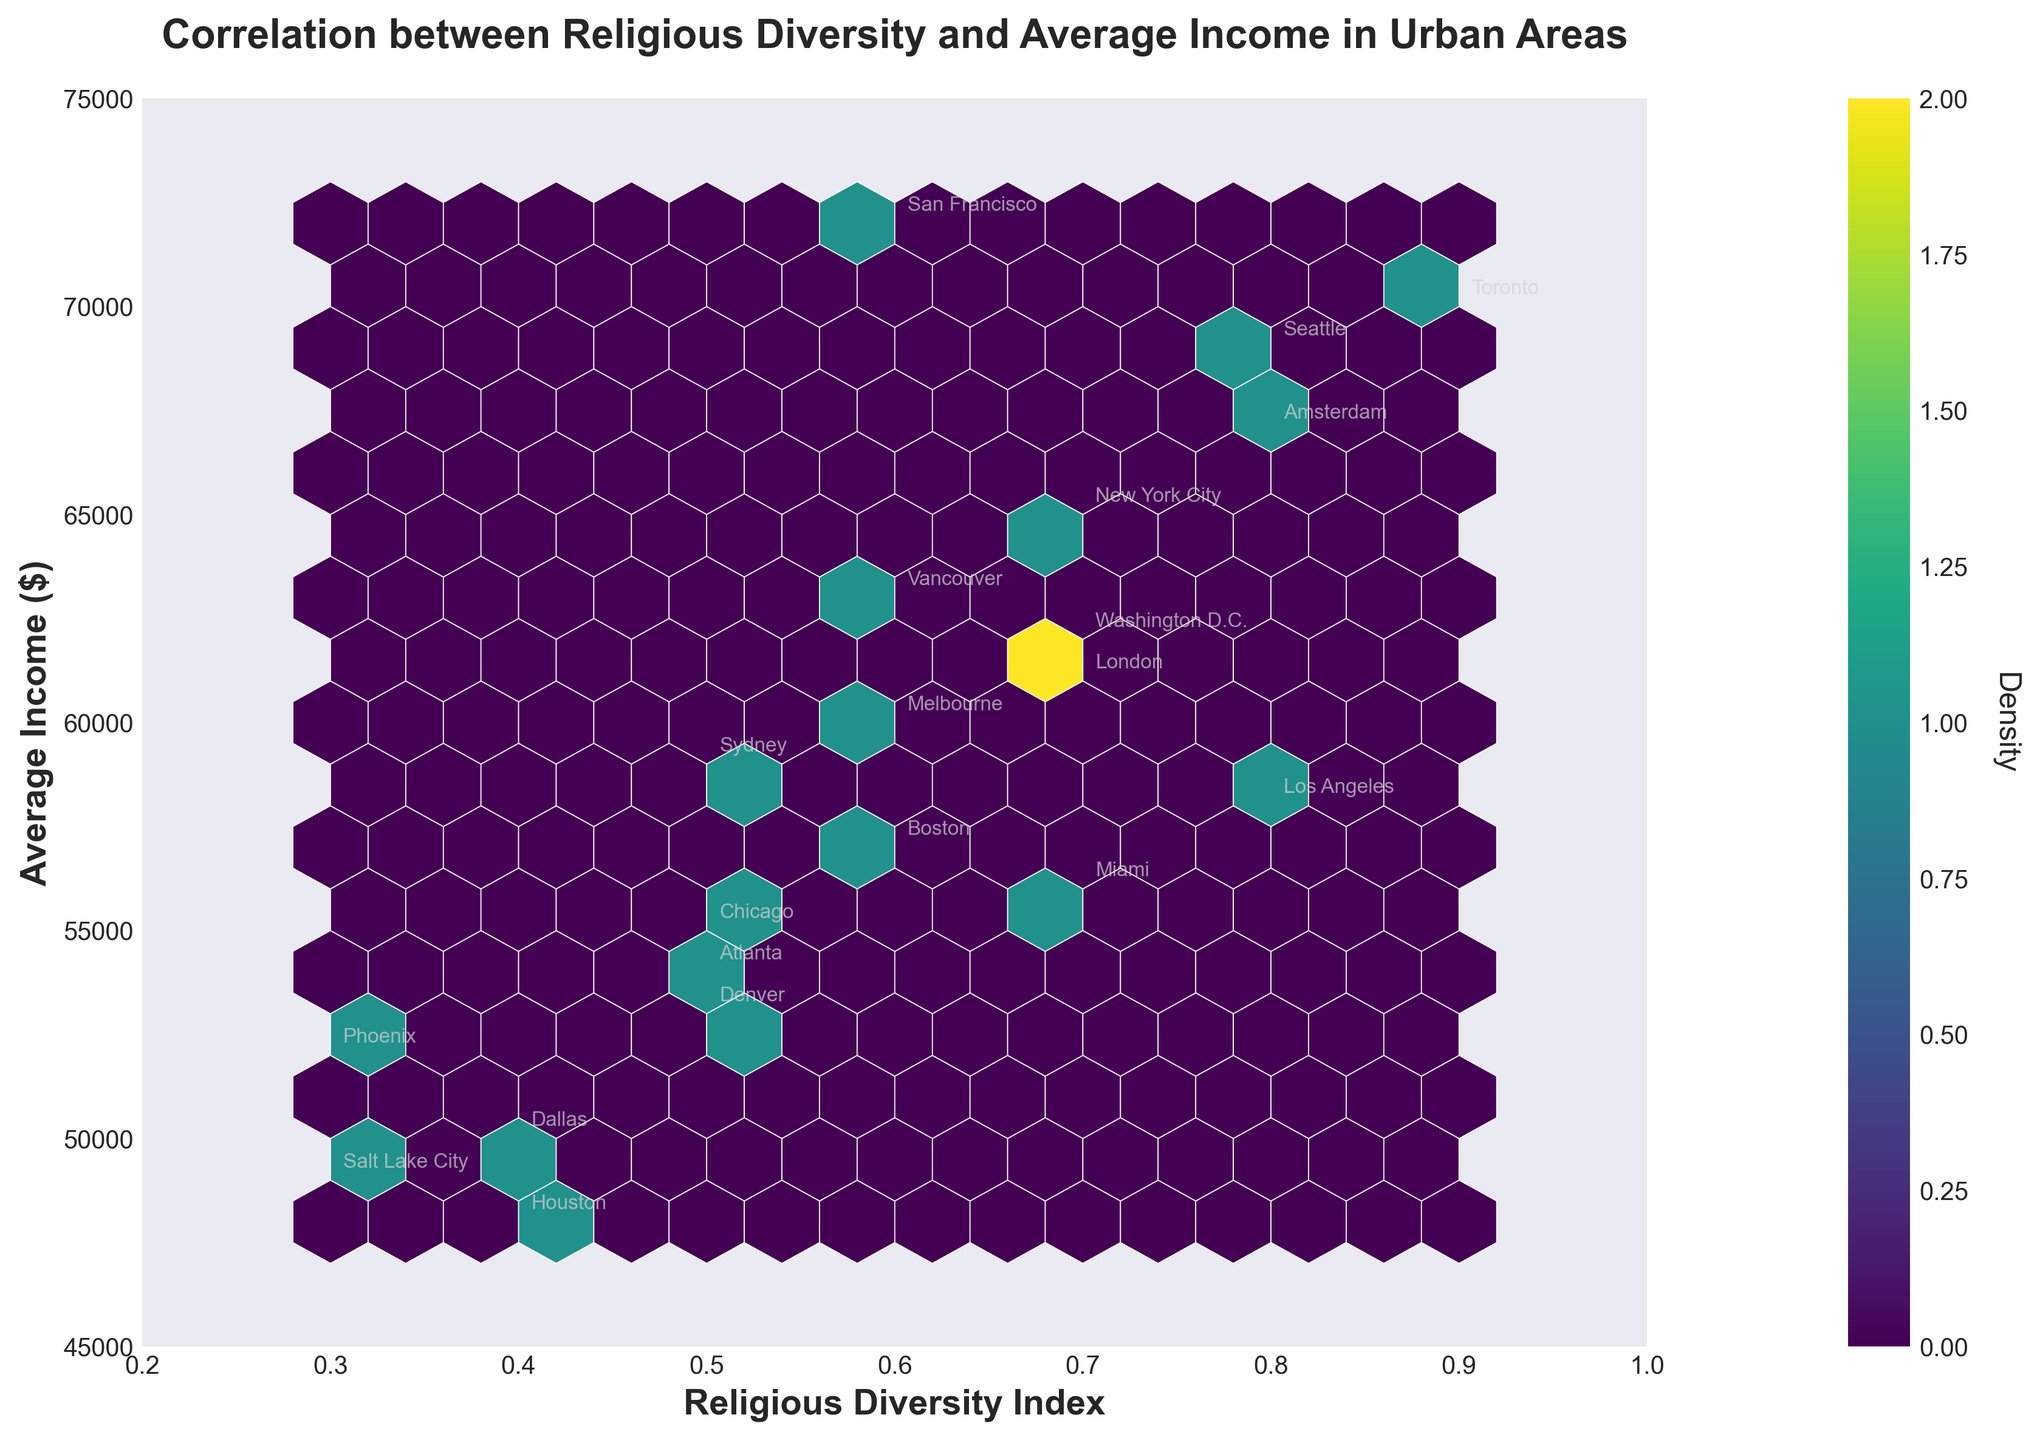What is the title of the plot? The title is located at the top of the plot and typically summarizes the main theme or focus of the visual. In this plot, the title indicates the relationship being studied.
Answer: Correlation between Religious Diversity and Average Income in Urban Areas What do the x-axis and y-axis represent? The labels on the axes provide this information. The x-axis is labeled 'Religious Diversity Index' and the y-axis is labeled 'Average Income ($)'.
Answer: Religious Diversity Index and Average Income ($) What city corresponds to the point with the highest Religious Diversity Index? By examining the highest value on the x-axis and identifying the annotated city closest to that point, you can determine which city has the highest Religious Diversity Index.
Answer: Toronto What is the density measure represented by the colorbar? The colorbar, typically located beside the plot, annotates the density of the data points. The label of the colorbar in this plot indicates what it measures.
Answer: Density Which city has the lowest average income among those with a Religious Diversity Index of 0.5? By identifying the cities with a Religious Diversity Index of 0.5, you can compare their Average Incomes and find the lowest one. Chicago, Sydney, and Denver have a Diversity Index of 0.5, with `Denver` having the lowest income.
Answer: Denver Is there a general trend between Religious Diversity Index and Average Income indicated in the plot? Observing the general distribution of hexagons helps see if Average Income increases or decreases with changes in the Religious Diversity Index. This plot shows a positive correlation; as the Religious Diversity Index increases, the Average Income tends to also increase.
Answer: Yes, a positive correlation Which city has the highest average income among those with a Religious Diversity Index of 0.7? By identifying the cities with a Religious Diversity Index of 0.7 and comparing their Average Incomes, you can list the highest one. New York City, London, Miami, and Washington D.C. have this index. New York City has the highest income among these.
Answer: New York City What observed range of values is covered by the colorbar? The colorbar shows the range of densities found within the hexbin plot, and it extends from a minimum to maximum density. Observing the color legend beside the plot, you can identify the density values.
Answer: Minimum to Maximum Density How many cities have a Religious Diversity Index of 0.4? By counting the number of city annotations at 0.4 on the x-axis, you determine the number of cities with this index. Houston and Dallas have this value.
Answer: 2 Which city exhibits both a high Religious Diversity Index and a high average income? By finding points near the upper right of the plot which are annotated with city names, and confirming they have one of the higher average incomes and diversity indices, you identify such cities. Toronto and Los Angeles match these criteria.
Answer: Toronto 